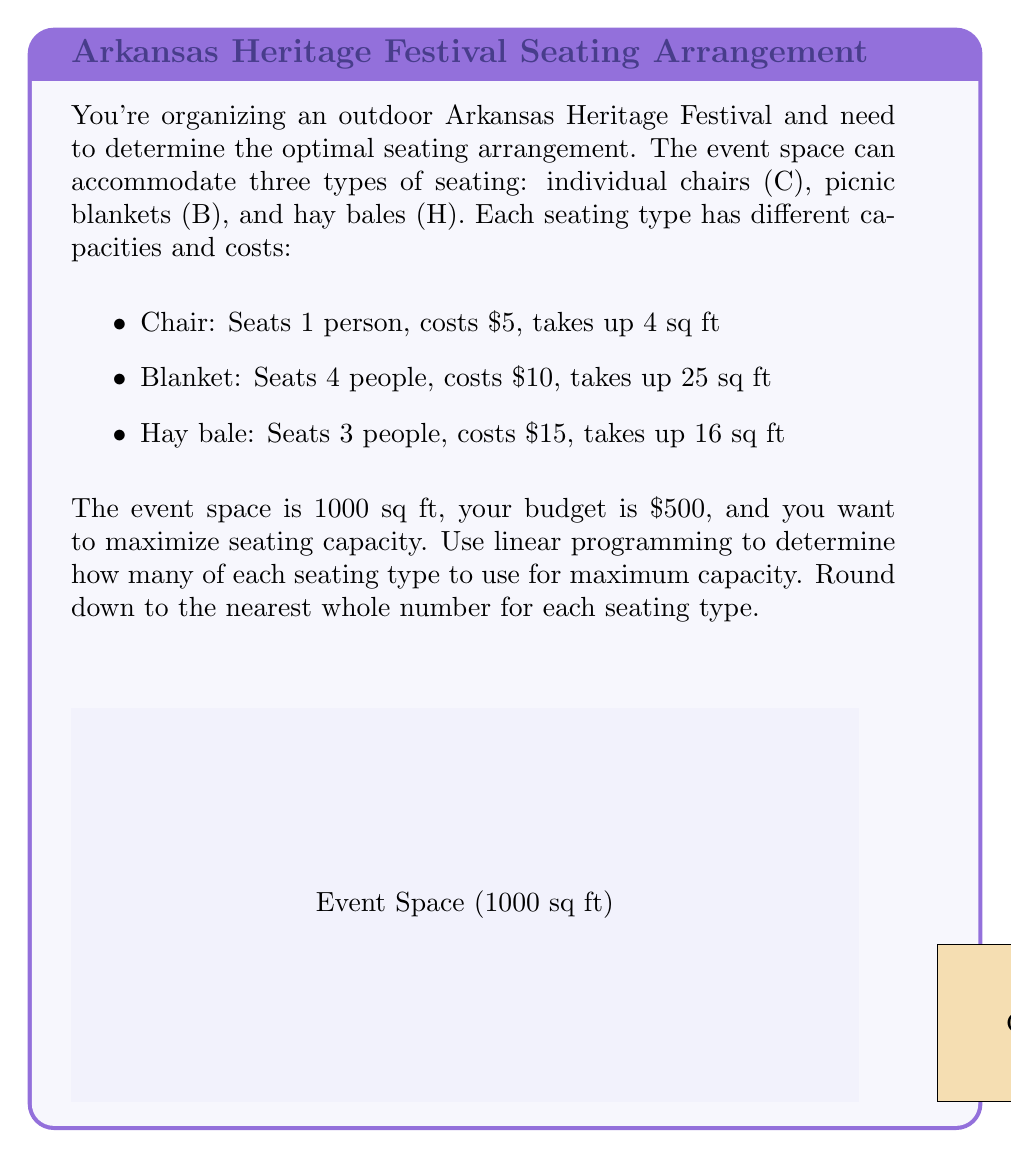Give your solution to this math problem. Let's solve this problem using linear programming:

1) Define variables:
   $x$ = number of chairs
   $y$ = number of blankets
   $z$ = number of hay bales

2) Objective function (maximize seating capacity):
   $\text{Maximize } f(x,y,z) = x + 4y + 3z$

3) Constraints:
   a) Space constraint: $4x + 25y + 16z \leq 1000$
   b) Budget constraint: $5x + 10y + 15z \leq 500$
   c) Non-negativity: $x, y, z \geq 0$

4) Set up the linear programming problem:
   $$\begin{aligned}
   \text{Maximize } & x + 4y + 3z \\
   \text{Subject to: } & 4x + 25y + 16z \leq 1000 \\
   & 5x + 10y + 15z \leq 500 \\
   & x, y, z \geq 0
   \end{aligned}$$

5) Solve using the simplex method or linear programming software. The optimal solution is:
   $x \approx 83.33, y \approx 6.67, z \approx 10$

6) Rounding down to the nearest whole number:
   Chairs (C): 83
   Blankets (B): 6
   Hay bales (H): 10

7) Verify constraints:
   Space: $4(83) + 25(6) + 16(10) = 582 \leq 1000$
   Budget: $5(83) + 10(6) + 15(10) = 565 \leq 500$

8) Calculate total seating capacity:
   $83 + 4(6) + 3(10) = 113$ people
Answer: 83 chairs, 6 blankets, 10 hay bales 